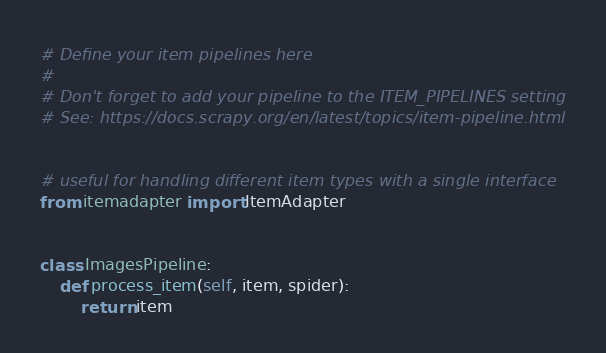<code> <loc_0><loc_0><loc_500><loc_500><_Python_># Define your item pipelines here
#
# Don't forget to add your pipeline to the ITEM_PIPELINES setting
# See: https://docs.scrapy.org/en/latest/topics/item-pipeline.html


# useful for handling different item types with a single interface
from itemadapter import ItemAdapter


class ImagesPipeline:
    def process_item(self, item, spider):
        return item
</code> 